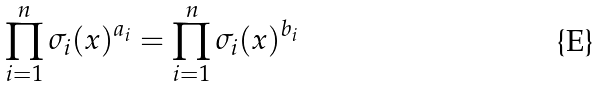Convert formula to latex. <formula><loc_0><loc_0><loc_500><loc_500>\prod _ { i = 1 } ^ { n } \sigma _ { i } ( x ) ^ { a _ { i } } = \prod _ { i = 1 } ^ { n } \sigma _ { i } ( x ) ^ { b _ { i } }</formula> 